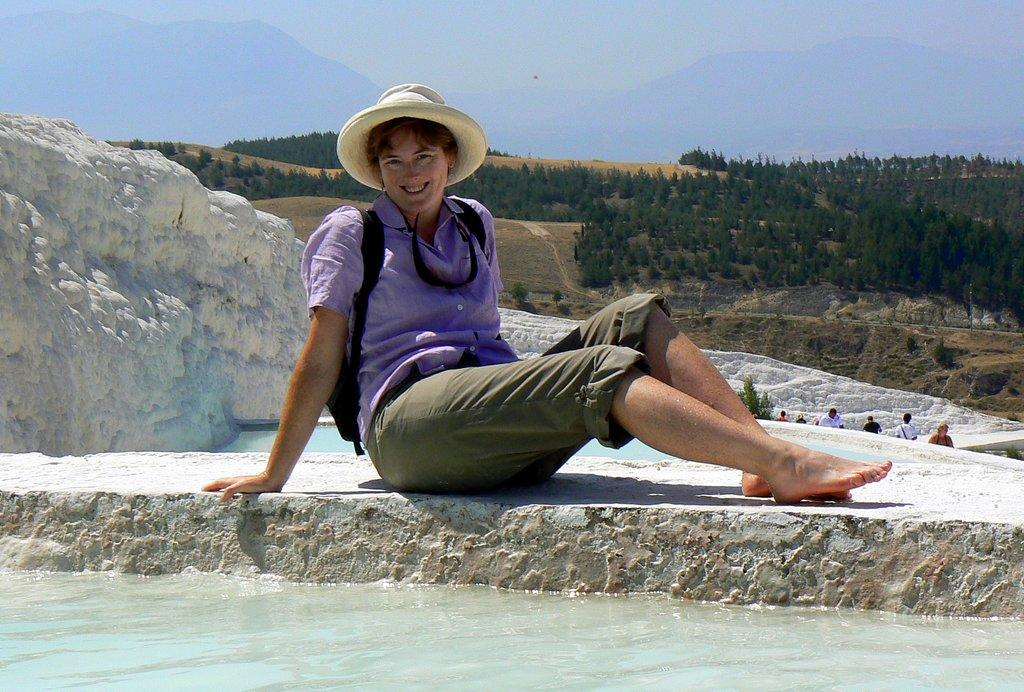What is the lady in the center of the image doing? The lady is sitting and smiling in the center of the image. What can be seen at the bottom of the image? There is water at the bottom of the image. What is visible in the background of the image? Hills, trees, and the sky are visible in the background of the image. Are there any other people in the image besides the lady? Yes, there are people on the right side of the image. What type of oven is being used by the beginner in the image? There is no oven or beginner present in the image. What is the lady writing in the image? The lady is not writing anything in the image; she is sitting and smiling. 